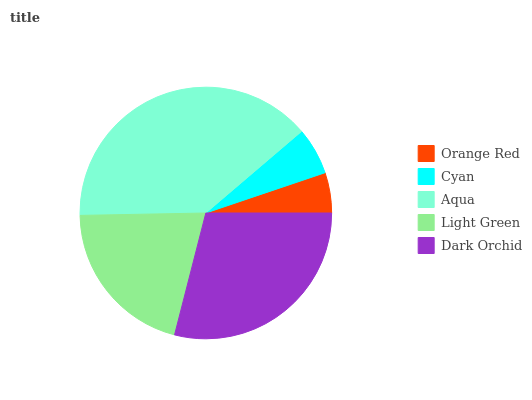Is Orange Red the minimum?
Answer yes or no. Yes. Is Aqua the maximum?
Answer yes or no. Yes. Is Cyan the minimum?
Answer yes or no. No. Is Cyan the maximum?
Answer yes or no. No. Is Cyan greater than Orange Red?
Answer yes or no. Yes. Is Orange Red less than Cyan?
Answer yes or no. Yes. Is Orange Red greater than Cyan?
Answer yes or no. No. Is Cyan less than Orange Red?
Answer yes or no. No. Is Light Green the high median?
Answer yes or no. Yes. Is Light Green the low median?
Answer yes or no. Yes. Is Aqua the high median?
Answer yes or no. No. Is Aqua the low median?
Answer yes or no. No. 